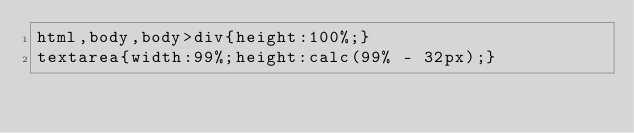Convert code to text. <code><loc_0><loc_0><loc_500><loc_500><_CSS_>html,body,body>div{height:100%;}
textarea{width:99%;height:calc(99% - 32px);}
</code> 